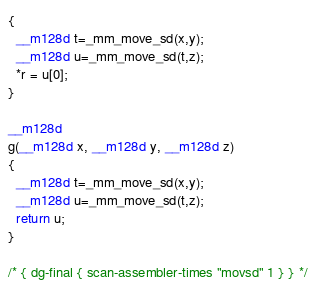Convert code to text. <code><loc_0><loc_0><loc_500><loc_500><_C_>{
  __m128d t=_mm_move_sd(x,y);
  __m128d u=_mm_move_sd(t,z);
  *r = u[0];
}

__m128d
g(__m128d x, __m128d y, __m128d z)
{
  __m128d t=_mm_move_sd(x,y);
  __m128d u=_mm_move_sd(t,z);
  return u;
}

/* { dg-final { scan-assembler-times "movsd" 1 } } */
</code> 